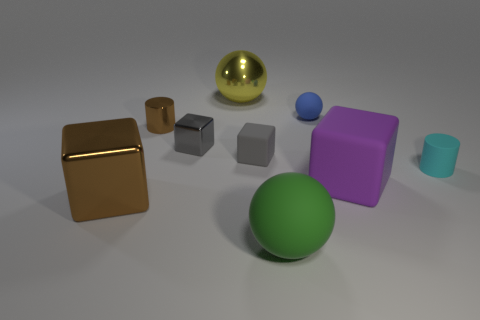Subtract 1 cubes. How many cubes are left? 3 Add 1 metal objects. How many objects exist? 10 Subtract all blue blocks. Subtract all red spheres. How many blocks are left? 4 Subtract all cylinders. How many objects are left? 7 Add 3 gray matte cubes. How many gray matte cubes exist? 4 Subtract 0 cyan blocks. How many objects are left? 9 Subtract all gray cubes. Subtract all rubber blocks. How many objects are left? 5 Add 8 brown cubes. How many brown cubes are left? 9 